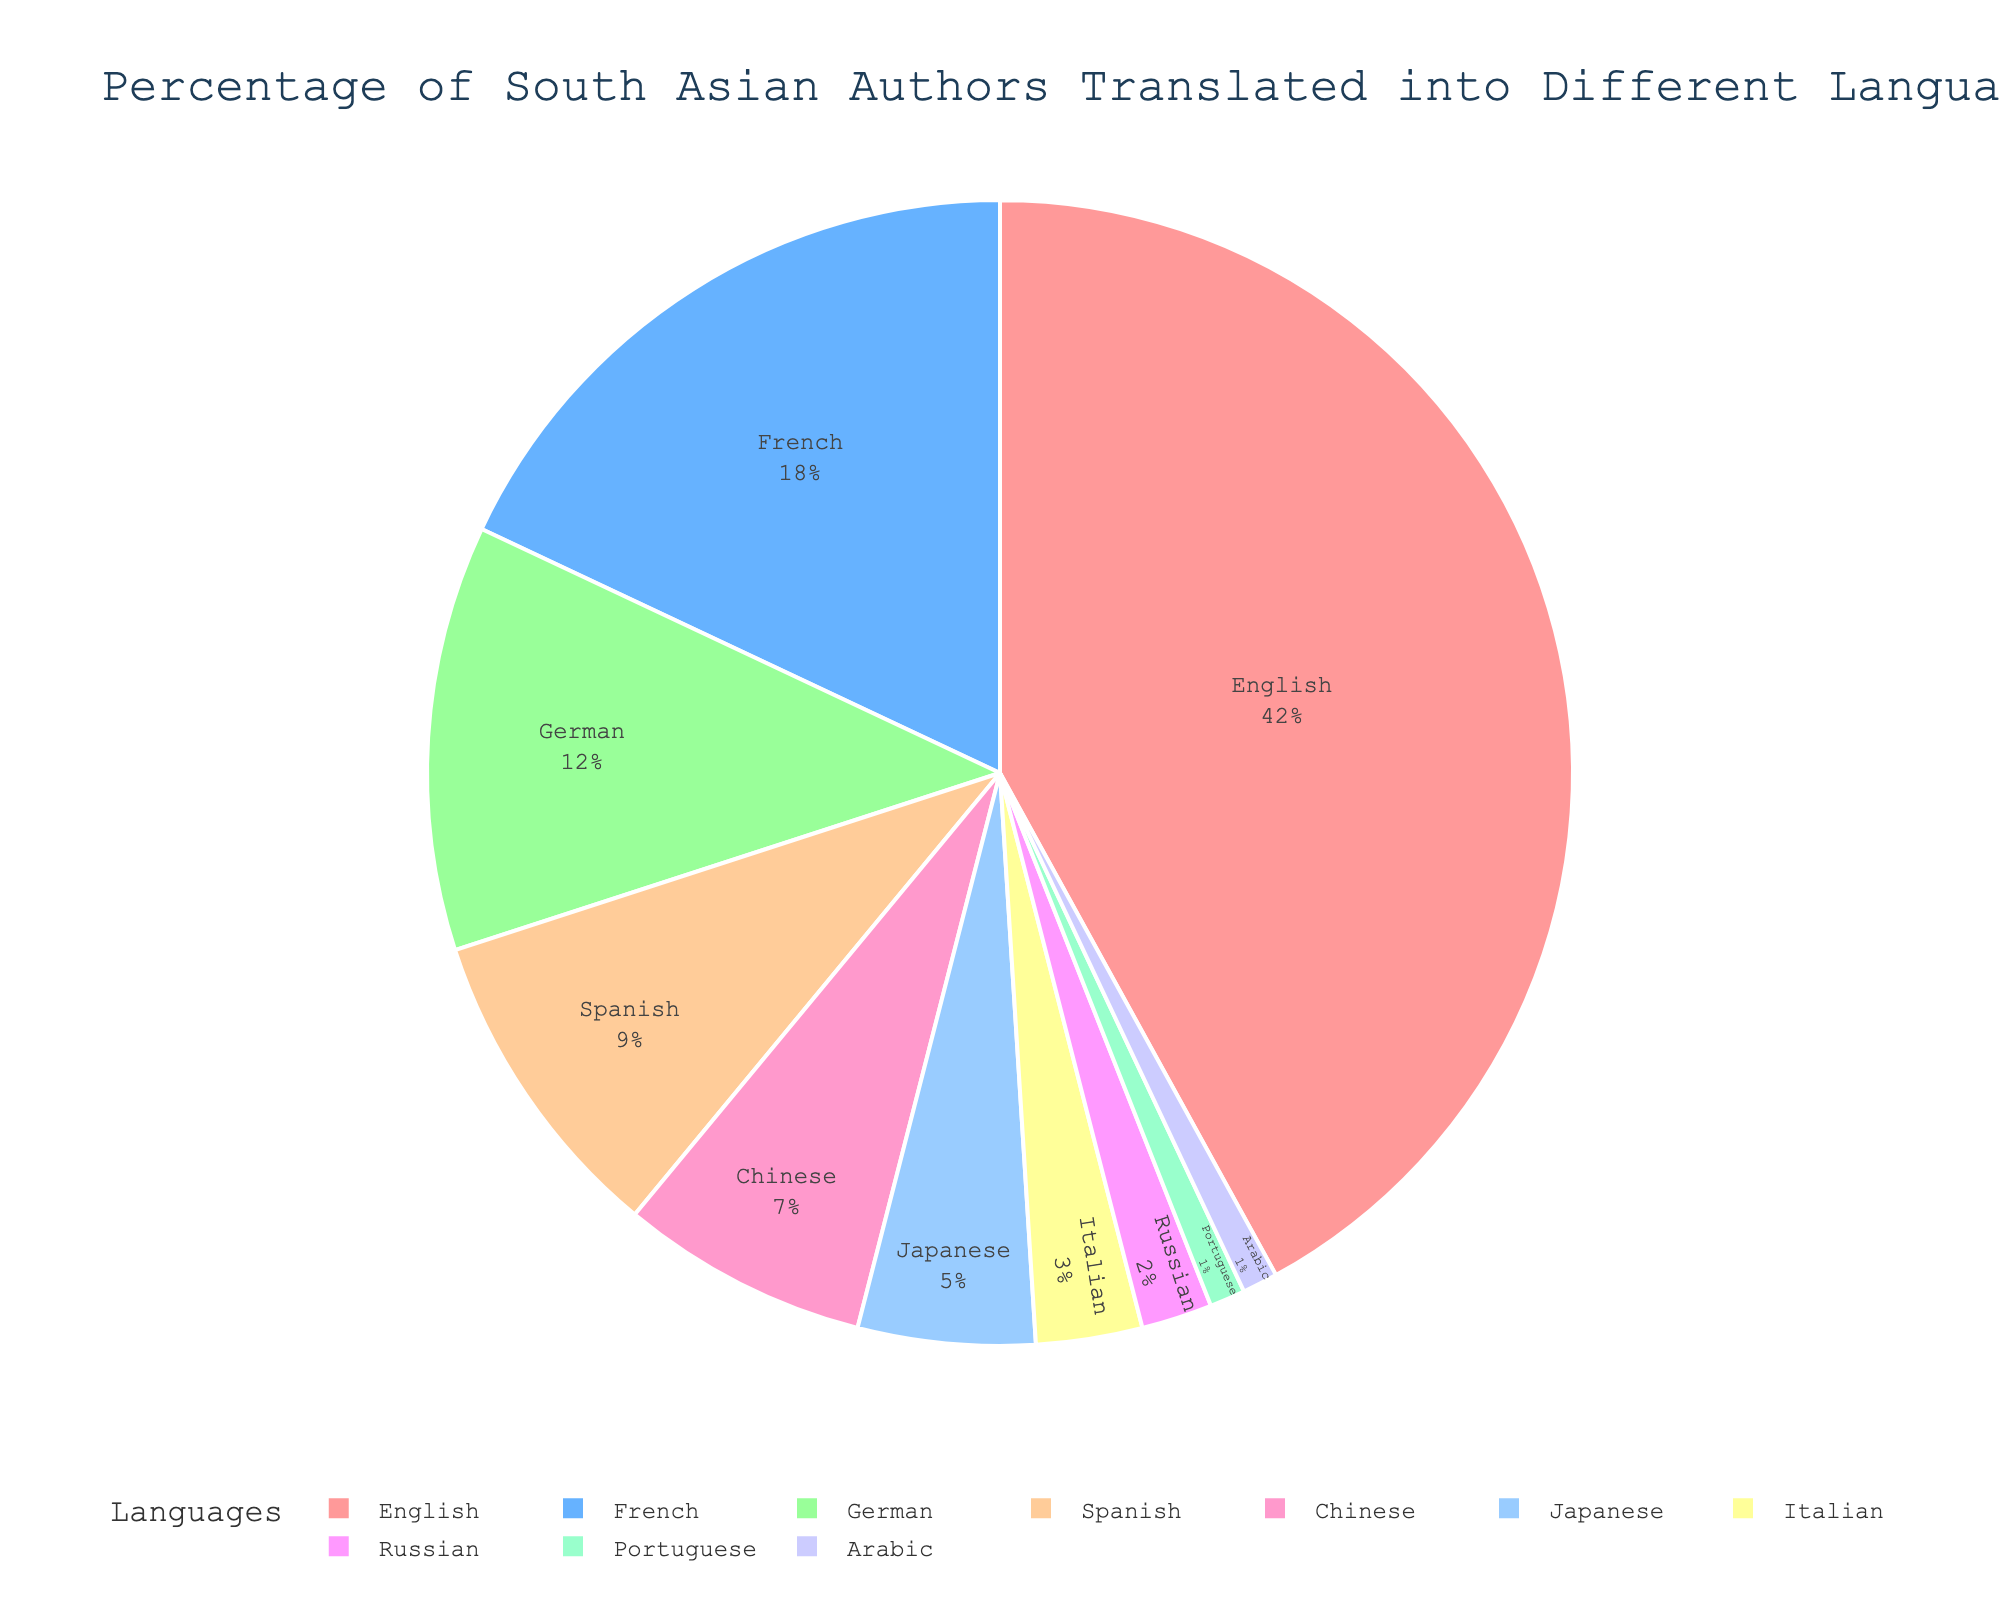What percentage of South Asian authors are translated into English? Locate the segment labeled "English" in the pie chart. The percentage displayed next to it is 42%.
Answer: 42% Which language represents the smallest percentage of translations? Observe the pie chart segments to identify the smallest slice, which is labeled "Portuguese" and "Arabic" with each having 1%.
Answer: Portuguese and Arabic What is the combined percentage for translations into French, German, and Spanish? Add the percentages for French (18%), German (12%), and Spanish (9%). The total is 18 + 12 + 9 = 39%.
Answer: 39% Which languages have more than 10% of translations? Look for segments with percentages greater than 10. These are "English" (42%), "French" (18%), and "German" (12%).
Answer: English, French, and German What is the difference in percentage between translations into Chinese and Japanese? Subtract the percentage for Japanese (5%) from Chinese (7%). The difference is 7 - 5 = 2%.
Answer: 2% Order the languages by the percentage of translations from highest to lowest. The segments can be ordered as follows: English (42%), French (18%), German (12%), Spanish (9%), Chinese (7%), Japanese (5%), Italian (3%), Russian (2%), Portuguese (1%), Arabic (1%).
Answer: English, French, German, Spanish, Chinese, Japanese, Italian, Russian, Portuguese, Arabic What is the total percentage for translations into non-European languages (Chinese, Japanese, and Arabic)? Add the percentages for Chinese (7%), Japanese (5%), and Arabic (1%). The total is 7 + 5 + 1 = 13%.
Answer: 13% Which color represents the Italian language segment? Identify the color associated with the "Italian" segment. It is light blue.
Answer: Light blue How many languages have a percentage less than 5%? Count segments with less than 5%: Japanese (5%), Italian (3%), Russian (2%), Portuguese (1%), and Arabic (1%), totaling 5 languages.
Answer: 5 Is the percentage of translations into French more than double that of Spanish? Compare French (18%) to Spanish (9%). Double of Spanish is 9 * 2 = 18%. French is exactly 18%, which is double of Spanish.
Answer: Yes 